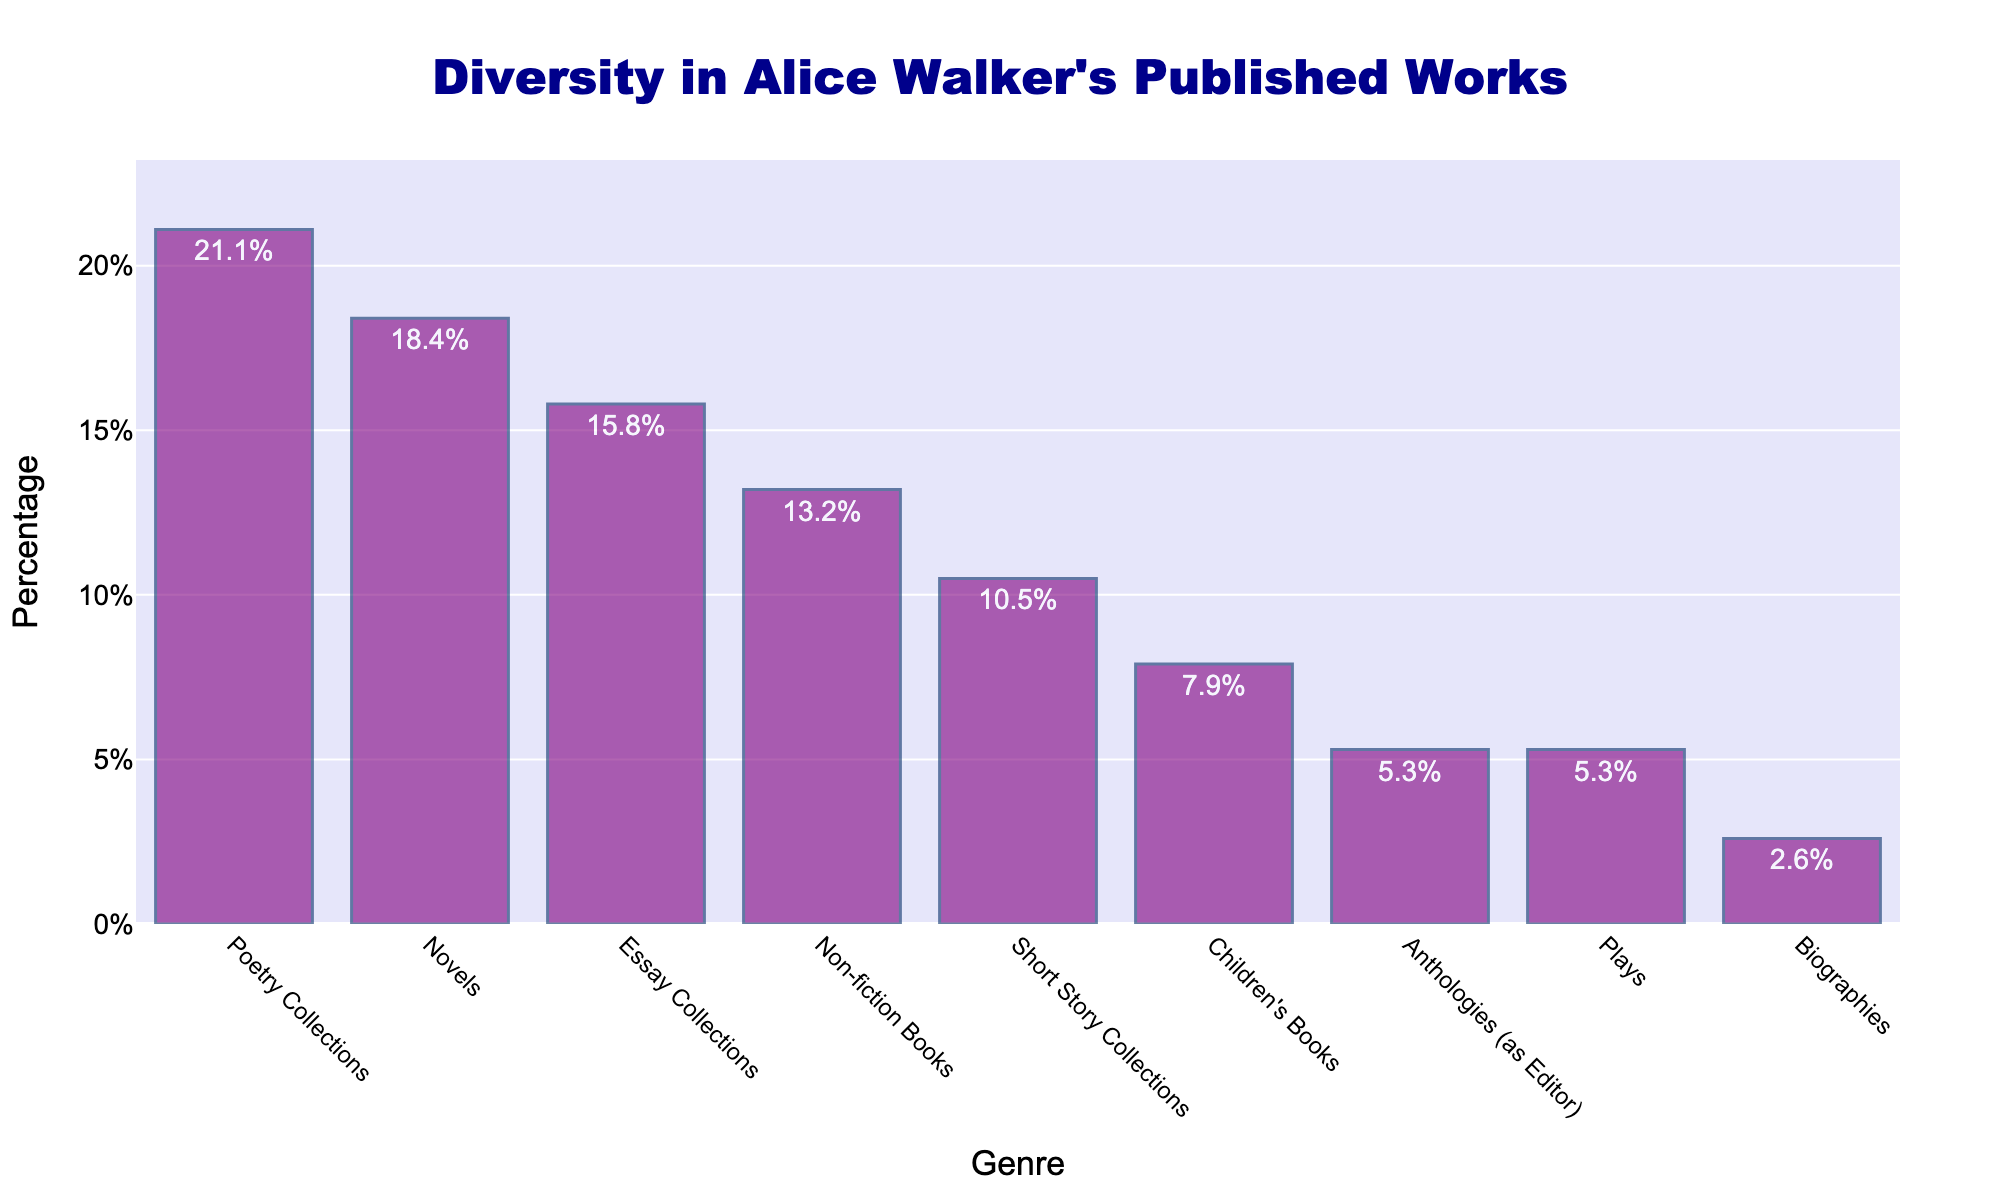What genre has the highest percentage of Alice Walker's works? Looking at the figure, the bar with the highest percentage is the one corresponding to Poetry Collections, which is 21.1%.
Answer: Poetry Collections Which genre has the lowest percentage of Alice Walker's works? Observing the figure, the bar with the lowest percentage is the one for Biographies, which stands at 2.6%.
Answer: Biographies What is the total percentage of Alice Walker's works that are either Novels or Essay Collections? From the figure, Novels constitute 18.4% and Essay Collections 15.8%. Adding these gives 18.4% + 15.8% = 34.2%.
Answer: 34.2% How does the number of Poetry Collections compare to the number of Children's Books? The figure shows 21.1% for Poetry Collections and 7.9% for Children's Books. Poetry Collections have a significantly higher percentage, indicating they are more frequent in her works.
Answer: Poetry Collections are more frequent Which genres are represented equally in Alice Walker's works? The bars for Anthologies (as Editor) and Plays both show a percentage of 5.3%, indicating an equal representation.
Answer: Anthologies (as Editor) and Plays What is the combined percentage of genres that have fewer than 10% representation? From the figure, Short Story Collections (10.5%), Children's Books (7.9%), Anthologies (as Editor) (5.3%), Plays (5.3%), and Biographies (2.6%). Adding percentages of the genres with fewer than 10%: 7.9% + 5.3% + 5.3% + 2.6% = 21.1%.
Answer: 21.1% Does Alice Walker have more Essay Collections or Non-fiction Books and by how much? The figure shows 15.8% for Essay Collections and 13.2% for Non-fiction Books. Subtracting the percentages: 15.8% - 13.2% = 2.6%.
Answer: Essay Collections by 2.6% 